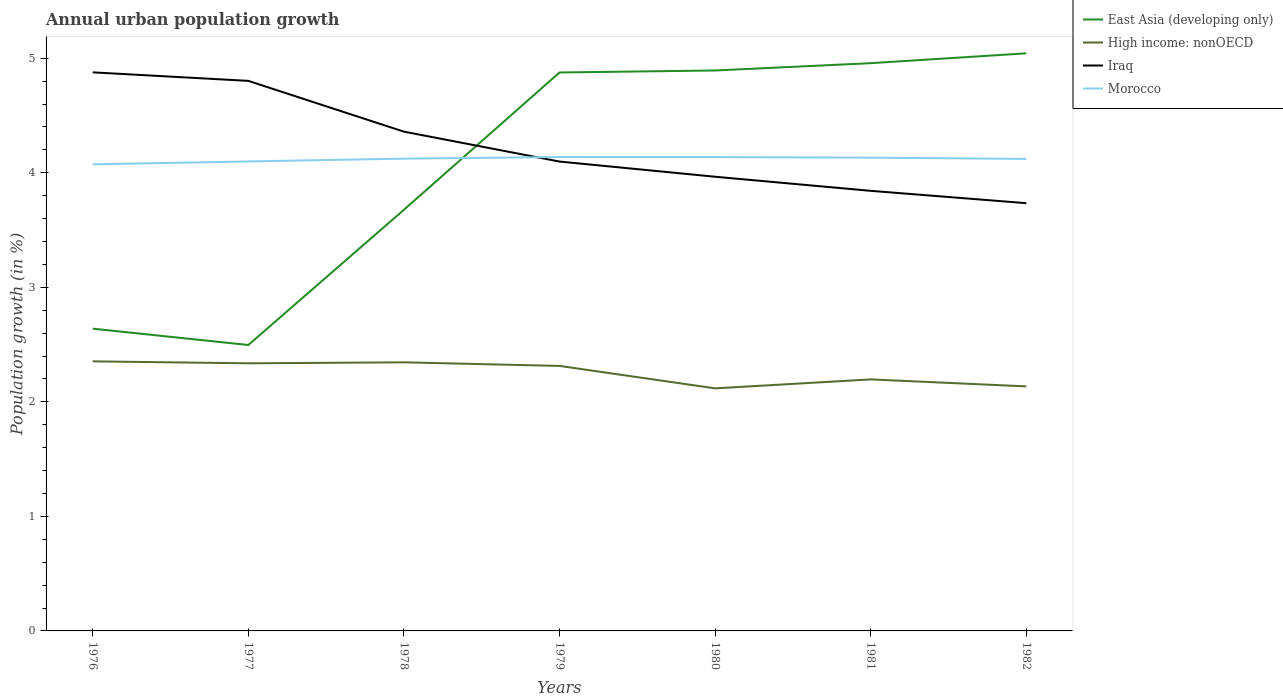How many different coloured lines are there?
Ensure brevity in your answer.  4. Does the line corresponding to Iraq intersect with the line corresponding to Morocco?
Give a very brief answer. Yes. Across all years, what is the maximum percentage of urban population growth in East Asia (developing only)?
Make the answer very short. 2.5. What is the total percentage of urban population growth in Iraq in the graph?
Give a very brief answer. 0.96. What is the difference between the highest and the second highest percentage of urban population growth in East Asia (developing only)?
Ensure brevity in your answer.  2.55. What is the difference between the highest and the lowest percentage of urban population growth in East Asia (developing only)?
Ensure brevity in your answer.  4. How many lines are there?
Make the answer very short. 4. Are the values on the major ticks of Y-axis written in scientific E-notation?
Keep it short and to the point. No. What is the title of the graph?
Your response must be concise. Annual urban population growth. Does "Belize" appear as one of the legend labels in the graph?
Make the answer very short. No. What is the label or title of the Y-axis?
Provide a succinct answer. Population growth (in %). What is the Population growth (in %) in East Asia (developing only) in 1976?
Ensure brevity in your answer.  2.64. What is the Population growth (in %) of High income: nonOECD in 1976?
Your response must be concise. 2.35. What is the Population growth (in %) of Iraq in 1976?
Your answer should be very brief. 4.88. What is the Population growth (in %) in Morocco in 1976?
Offer a very short reply. 4.07. What is the Population growth (in %) in East Asia (developing only) in 1977?
Your answer should be compact. 2.5. What is the Population growth (in %) in High income: nonOECD in 1977?
Provide a short and direct response. 2.34. What is the Population growth (in %) of Iraq in 1977?
Keep it short and to the point. 4.8. What is the Population growth (in %) in Morocco in 1977?
Give a very brief answer. 4.1. What is the Population growth (in %) in East Asia (developing only) in 1978?
Ensure brevity in your answer.  3.68. What is the Population growth (in %) of High income: nonOECD in 1978?
Make the answer very short. 2.35. What is the Population growth (in %) in Iraq in 1978?
Your answer should be compact. 4.36. What is the Population growth (in %) of Morocco in 1978?
Provide a succinct answer. 4.12. What is the Population growth (in %) in East Asia (developing only) in 1979?
Offer a very short reply. 4.88. What is the Population growth (in %) in High income: nonOECD in 1979?
Provide a succinct answer. 2.31. What is the Population growth (in %) of Iraq in 1979?
Ensure brevity in your answer.  4.1. What is the Population growth (in %) of Morocco in 1979?
Your answer should be compact. 4.14. What is the Population growth (in %) in East Asia (developing only) in 1980?
Offer a terse response. 4.89. What is the Population growth (in %) of High income: nonOECD in 1980?
Provide a succinct answer. 2.12. What is the Population growth (in %) of Iraq in 1980?
Offer a very short reply. 3.97. What is the Population growth (in %) of Morocco in 1980?
Your response must be concise. 4.14. What is the Population growth (in %) in East Asia (developing only) in 1981?
Provide a succinct answer. 4.96. What is the Population growth (in %) of High income: nonOECD in 1981?
Provide a succinct answer. 2.2. What is the Population growth (in %) in Iraq in 1981?
Your answer should be very brief. 3.84. What is the Population growth (in %) of Morocco in 1981?
Provide a succinct answer. 4.13. What is the Population growth (in %) in East Asia (developing only) in 1982?
Your answer should be compact. 5.04. What is the Population growth (in %) in High income: nonOECD in 1982?
Your response must be concise. 2.13. What is the Population growth (in %) of Iraq in 1982?
Offer a terse response. 3.73. What is the Population growth (in %) in Morocco in 1982?
Your response must be concise. 4.12. Across all years, what is the maximum Population growth (in %) of East Asia (developing only)?
Your answer should be compact. 5.04. Across all years, what is the maximum Population growth (in %) of High income: nonOECD?
Offer a terse response. 2.35. Across all years, what is the maximum Population growth (in %) in Iraq?
Your answer should be compact. 4.88. Across all years, what is the maximum Population growth (in %) of Morocco?
Your response must be concise. 4.14. Across all years, what is the minimum Population growth (in %) of East Asia (developing only)?
Your answer should be compact. 2.5. Across all years, what is the minimum Population growth (in %) in High income: nonOECD?
Provide a short and direct response. 2.12. Across all years, what is the minimum Population growth (in %) in Iraq?
Make the answer very short. 3.73. Across all years, what is the minimum Population growth (in %) in Morocco?
Make the answer very short. 4.07. What is the total Population growth (in %) in East Asia (developing only) in the graph?
Make the answer very short. 28.58. What is the total Population growth (in %) of High income: nonOECD in the graph?
Your response must be concise. 15.8. What is the total Population growth (in %) in Iraq in the graph?
Your answer should be compact. 29.68. What is the total Population growth (in %) of Morocco in the graph?
Your answer should be very brief. 28.82. What is the difference between the Population growth (in %) of East Asia (developing only) in 1976 and that in 1977?
Offer a terse response. 0.14. What is the difference between the Population growth (in %) in High income: nonOECD in 1976 and that in 1977?
Your answer should be compact. 0.02. What is the difference between the Population growth (in %) of Iraq in 1976 and that in 1977?
Your answer should be compact. 0.07. What is the difference between the Population growth (in %) in Morocco in 1976 and that in 1977?
Your answer should be compact. -0.03. What is the difference between the Population growth (in %) in East Asia (developing only) in 1976 and that in 1978?
Your response must be concise. -1.04. What is the difference between the Population growth (in %) of High income: nonOECD in 1976 and that in 1978?
Ensure brevity in your answer.  0.01. What is the difference between the Population growth (in %) in Iraq in 1976 and that in 1978?
Provide a succinct answer. 0.52. What is the difference between the Population growth (in %) of Morocco in 1976 and that in 1978?
Keep it short and to the point. -0.05. What is the difference between the Population growth (in %) in East Asia (developing only) in 1976 and that in 1979?
Provide a short and direct response. -2.24. What is the difference between the Population growth (in %) of Iraq in 1976 and that in 1979?
Make the answer very short. 0.78. What is the difference between the Population growth (in %) in Morocco in 1976 and that in 1979?
Make the answer very short. -0.06. What is the difference between the Population growth (in %) of East Asia (developing only) in 1976 and that in 1980?
Offer a terse response. -2.25. What is the difference between the Population growth (in %) of High income: nonOECD in 1976 and that in 1980?
Provide a short and direct response. 0.24. What is the difference between the Population growth (in %) of Iraq in 1976 and that in 1980?
Make the answer very short. 0.91. What is the difference between the Population growth (in %) of Morocco in 1976 and that in 1980?
Your answer should be compact. -0.06. What is the difference between the Population growth (in %) of East Asia (developing only) in 1976 and that in 1981?
Your answer should be very brief. -2.32. What is the difference between the Population growth (in %) in High income: nonOECD in 1976 and that in 1981?
Keep it short and to the point. 0.16. What is the difference between the Population growth (in %) in Iraq in 1976 and that in 1981?
Offer a very short reply. 1.03. What is the difference between the Population growth (in %) of Morocco in 1976 and that in 1981?
Your response must be concise. -0.06. What is the difference between the Population growth (in %) in East Asia (developing only) in 1976 and that in 1982?
Provide a short and direct response. -2.4. What is the difference between the Population growth (in %) in High income: nonOECD in 1976 and that in 1982?
Offer a terse response. 0.22. What is the difference between the Population growth (in %) in Iraq in 1976 and that in 1982?
Offer a very short reply. 1.14. What is the difference between the Population growth (in %) of Morocco in 1976 and that in 1982?
Ensure brevity in your answer.  -0.05. What is the difference between the Population growth (in %) of East Asia (developing only) in 1977 and that in 1978?
Your answer should be compact. -1.18. What is the difference between the Population growth (in %) in High income: nonOECD in 1977 and that in 1978?
Keep it short and to the point. -0.01. What is the difference between the Population growth (in %) of Iraq in 1977 and that in 1978?
Your response must be concise. 0.44. What is the difference between the Population growth (in %) of Morocco in 1977 and that in 1978?
Your response must be concise. -0.02. What is the difference between the Population growth (in %) in East Asia (developing only) in 1977 and that in 1979?
Keep it short and to the point. -2.38. What is the difference between the Population growth (in %) in High income: nonOECD in 1977 and that in 1979?
Your answer should be compact. 0.02. What is the difference between the Population growth (in %) of Iraq in 1977 and that in 1979?
Your answer should be compact. 0.7. What is the difference between the Population growth (in %) in Morocco in 1977 and that in 1979?
Your answer should be compact. -0.04. What is the difference between the Population growth (in %) in East Asia (developing only) in 1977 and that in 1980?
Provide a succinct answer. -2.4. What is the difference between the Population growth (in %) of High income: nonOECD in 1977 and that in 1980?
Your answer should be very brief. 0.22. What is the difference between the Population growth (in %) of Iraq in 1977 and that in 1980?
Offer a very short reply. 0.84. What is the difference between the Population growth (in %) of Morocco in 1977 and that in 1980?
Ensure brevity in your answer.  -0.04. What is the difference between the Population growth (in %) of East Asia (developing only) in 1977 and that in 1981?
Offer a very short reply. -2.46. What is the difference between the Population growth (in %) of High income: nonOECD in 1977 and that in 1981?
Provide a short and direct response. 0.14. What is the difference between the Population growth (in %) in Iraq in 1977 and that in 1981?
Keep it short and to the point. 0.96. What is the difference between the Population growth (in %) of Morocco in 1977 and that in 1981?
Provide a short and direct response. -0.03. What is the difference between the Population growth (in %) of East Asia (developing only) in 1977 and that in 1982?
Your answer should be very brief. -2.55. What is the difference between the Population growth (in %) of High income: nonOECD in 1977 and that in 1982?
Give a very brief answer. 0.2. What is the difference between the Population growth (in %) of Iraq in 1977 and that in 1982?
Make the answer very short. 1.07. What is the difference between the Population growth (in %) of Morocco in 1977 and that in 1982?
Your answer should be compact. -0.02. What is the difference between the Population growth (in %) of East Asia (developing only) in 1978 and that in 1979?
Ensure brevity in your answer.  -1.2. What is the difference between the Population growth (in %) of High income: nonOECD in 1978 and that in 1979?
Offer a terse response. 0.03. What is the difference between the Population growth (in %) in Iraq in 1978 and that in 1979?
Your response must be concise. 0.26. What is the difference between the Population growth (in %) in Morocco in 1978 and that in 1979?
Keep it short and to the point. -0.01. What is the difference between the Population growth (in %) of East Asia (developing only) in 1978 and that in 1980?
Provide a succinct answer. -1.22. What is the difference between the Population growth (in %) of High income: nonOECD in 1978 and that in 1980?
Offer a very short reply. 0.23. What is the difference between the Population growth (in %) of Iraq in 1978 and that in 1980?
Ensure brevity in your answer.  0.39. What is the difference between the Population growth (in %) of Morocco in 1978 and that in 1980?
Offer a very short reply. -0.01. What is the difference between the Population growth (in %) in East Asia (developing only) in 1978 and that in 1981?
Your answer should be compact. -1.28. What is the difference between the Population growth (in %) in High income: nonOECD in 1978 and that in 1981?
Your answer should be very brief. 0.15. What is the difference between the Population growth (in %) in Iraq in 1978 and that in 1981?
Provide a succinct answer. 0.52. What is the difference between the Population growth (in %) in Morocco in 1978 and that in 1981?
Provide a succinct answer. -0.01. What is the difference between the Population growth (in %) in East Asia (developing only) in 1978 and that in 1982?
Keep it short and to the point. -1.37. What is the difference between the Population growth (in %) in High income: nonOECD in 1978 and that in 1982?
Offer a terse response. 0.21. What is the difference between the Population growth (in %) of Iraq in 1978 and that in 1982?
Keep it short and to the point. 0.62. What is the difference between the Population growth (in %) of Morocco in 1978 and that in 1982?
Provide a succinct answer. 0. What is the difference between the Population growth (in %) of East Asia (developing only) in 1979 and that in 1980?
Offer a very short reply. -0.02. What is the difference between the Population growth (in %) of High income: nonOECD in 1979 and that in 1980?
Provide a short and direct response. 0.2. What is the difference between the Population growth (in %) in Iraq in 1979 and that in 1980?
Ensure brevity in your answer.  0.13. What is the difference between the Population growth (in %) in East Asia (developing only) in 1979 and that in 1981?
Your answer should be compact. -0.08. What is the difference between the Population growth (in %) of High income: nonOECD in 1979 and that in 1981?
Give a very brief answer. 0.12. What is the difference between the Population growth (in %) of Iraq in 1979 and that in 1981?
Give a very brief answer. 0.26. What is the difference between the Population growth (in %) of Morocco in 1979 and that in 1981?
Give a very brief answer. 0.01. What is the difference between the Population growth (in %) of East Asia (developing only) in 1979 and that in 1982?
Your answer should be very brief. -0.17. What is the difference between the Population growth (in %) in High income: nonOECD in 1979 and that in 1982?
Offer a very short reply. 0.18. What is the difference between the Population growth (in %) of Iraq in 1979 and that in 1982?
Your answer should be compact. 0.36. What is the difference between the Population growth (in %) in Morocco in 1979 and that in 1982?
Provide a short and direct response. 0.02. What is the difference between the Population growth (in %) of East Asia (developing only) in 1980 and that in 1981?
Your answer should be very brief. -0.06. What is the difference between the Population growth (in %) of High income: nonOECD in 1980 and that in 1981?
Provide a short and direct response. -0.08. What is the difference between the Population growth (in %) in Iraq in 1980 and that in 1981?
Keep it short and to the point. 0.12. What is the difference between the Population growth (in %) of Morocco in 1980 and that in 1981?
Offer a terse response. 0.01. What is the difference between the Population growth (in %) in East Asia (developing only) in 1980 and that in 1982?
Give a very brief answer. -0.15. What is the difference between the Population growth (in %) of High income: nonOECD in 1980 and that in 1982?
Keep it short and to the point. -0.02. What is the difference between the Population growth (in %) in Iraq in 1980 and that in 1982?
Your response must be concise. 0.23. What is the difference between the Population growth (in %) in Morocco in 1980 and that in 1982?
Give a very brief answer. 0.02. What is the difference between the Population growth (in %) in East Asia (developing only) in 1981 and that in 1982?
Your answer should be compact. -0.09. What is the difference between the Population growth (in %) in High income: nonOECD in 1981 and that in 1982?
Your answer should be very brief. 0.06. What is the difference between the Population growth (in %) in Iraq in 1981 and that in 1982?
Offer a very short reply. 0.11. What is the difference between the Population growth (in %) in Morocco in 1981 and that in 1982?
Provide a short and direct response. 0.01. What is the difference between the Population growth (in %) of East Asia (developing only) in 1976 and the Population growth (in %) of High income: nonOECD in 1977?
Your response must be concise. 0.3. What is the difference between the Population growth (in %) of East Asia (developing only) in 1976 and the Population growth (in %) of Iraq in 1977?
Provide a short and direct response. -2.16. What is the difference between the Population growth (in %) of East Asia (developing only) in 1976 and the Population growth (in %) of Morocco in 1977?
Offer a very short reply. -1.46. What is the difference between the Population growth (in %) of High income: nonOECD in 1976 and the Population growth (in %) of Iraq in 1977?
Your response must be concise. -2.45. What is the difference between the Population growth (in %) of High income: nonOECD in 1976 and the Population growth (in %) of Morocco in 1977?
Give a very brief answer. -1.75. What is the difference between the Population growth (in %) of Iraq in 1976 and the Population growth (in %) of Morocco in 1977?
Offer a very short reply. 0.78. What is the difference between the Population growth (in %) of East Asia (developing only) in 1976 and the Population growth (in %) of High income: nonOECD in 1978?
Keep it short and to the point. 0.29. What is the difference between the Population growth (in %) in East Asia (developing only) in 1976 and the Population growth (in %) in Iraq in 1978?
Ensure brevity in your answer.  -1.72. What is the difference between the Population growth (in %) of East Asia (developing only) in 1976 and the Population growth (in %) of Morocco in 1978?
Ensure brevity in your answer.  -1.48. What is the difference between the Population growth (in %) of High income: nonOECD in 1976 and the Population growth (in %) of Iraq in 1978?
Provide a short and direct response. -2.01. What is the difference between the Population growth (in %) in High income: nonOECD in 1976 and the Population growth (in %) in Morocco in 1978?
Ensure brevity in your answer.  -1.77. What is the difference between the Population growth (in %) in Iraq in 1976 and the Population growth (in %) in Morocco in 1978?
Ensure brevity in your answer.  0.75. What is the difference between the Population growth (in %) in East Asia (developing only) in 1976 and the Population growth (in %) in High income: nonOECD in 1979?
Provide a succinct answer. 0.33. What is the difference between the Population growth (in %) of East Asia (developing only) in 1976 and the Population growth (in %) of Iraq in 1979?
Offer a very short reply. -1.46. What is the difference between the Population growth (in %) of East Asia (developing only) in 1976 and the Population growth (in %) of Morocco in 1979?
Your response must be concise. -1.5. What is the difference between the Population growth (in %) of High income: nonOECD in 1976 and the Population growth (in %) of Iraq in 1979?
Offer a very short reply. -1.74. What is the difference between the Population growth (in %) in High income: nonOECD in 1976 and the Population growth (in %) in Morocco in 1979?
Make the answer very short. -1.78. What is the difference between the Population growth (in %) in Iraq in 1976 and the Population growth (in %) in Morocco in 1979?
Your response must be concise. 0.74. What is the difference between the Population growth (in %) in East Asia (developing only) in 1976 and the Population growth (in %) in High income: nonOECD in 1980?
Your answer should be very brief. 0.52. What is the difference between the Population growth (in %) in East Asia (developing only) in 1976 and the Population growth (in %) in Iraq in 1980?
Offer a terse response. -1.33. What is the difference between the Population growth (in %) of East Asia (developing only) in 1976 and the Population growth (in %) of Morocco in 1980?
Your answer should be compact. -1.5. What is the difference between the Population growth (in %) of High income: nonOECD in 1976 and the Population growth (in %) of Iraq in 1980?
Provide a succinct answer. -1.61. What is the difference between the Population growth (in %) in High income: nonOECD in 1976 and the Population growth (in %) in Morocco in 1980?
Give a very brief answer. -1.78. What is the difference between the Population growth (in %) in Iraq in 1976 and the Population growth (in %) in Morocco in 1980?
Offer a terse response. 0.74. What is the difference between the Population growth (in %) of East Asia (developing only) in 1976 and the Population growth (in %) of High income: nonOECD in 1981?
Offer a terse response. 0.44. What is the difference between the Population growth (in %) in East Asia (developing only) in 1976 and the Population growth (in %) in Iraq in 1981?
Your answer should be very brief. -1.2. What is the difference between the Population growth (in %) of East Asia (developing only) in 1976 and the Population growth (in %) of Morocco in 1981?
Provide a succinct answer. -1.49. What is the difference between the Population growth (in %) of High income: nonOECD in 1976 and the Population growth (in %) of Iraq in 1981?
Make the answer very short. -1.49. What is the difference between the Population growth (in %) in High income: nonOECD in 1976 and the Population growth (in %) in Morocco in 1981?
Your answer should be compact. -1.78. What is the difference between the Population growth (in %) in Iraq in 1976 and the Population growth (in %) in Morocco in 1981?
Give a very brief answer. 0.74. What is the difference between the Population growth (in %) of East Asia (developing only) in 1976 and the Population growth (in %) of High income: nonOECD in 1982?
Offer a very short reply. 0.5. What is the difference between the Population growth (in %) in East Asia (developing only) in 1976 and the Population growth (in %) in Iraq in 1982?
Ensure brevity in your answer.  -1.1. What is the difference between the Population growth (in %) in East Asia (developing only) in 1976 and the Population growth (in %) in Morocco in 1982?
Offer a terse response. -1.48. What is the difference between the Population growth (in %) of High income: nonOECD in 1976 and the Population growth (in %) of Iraq in 1982?
Offer a very short reply. -1.38. What is the difference between the Population growth (in %) of High income: nonOECD in 1976 and the Population growth (in %) of Morocco in 1982?
Provide a succinct answer. -1.77. What is the difference between the Population growth (in %) of Iraq in 1976 and the Population growth (in %) of Morocco in 1982?
Ensure brevity in your answer.  0.76. What is the difference between the Population growth (in %) in East Asia (developing only) in 1977 and the Population growth (in %) in High income: nonOECD in 1978?
Keep it short and to the point. 0.15. What is the difference between the Population growth (in %) in East Asia (developing only) in 1977 and the Population growth (in %) in Iraq in 1978?
Your answer should be compact. -1.86. What is the difference between the Population growth (in %) of East Asia (developing only) in 1977 and the Population growth (in %) of Morocco in 1978?
Give a very brief answer. -1.63. What is the difference between the Population growth (in %) in High income: nonOECD in 1977 and the Population growth (in %) in Iraq in 1978?
Ensure brevity in your answer.  -2.02. What is the difference between the Population growth (in %) in High income: nonOECD in 1977 and the Population growth (in %) in Morocco in 1978?
Keep it short and to the point. -1.79. What is the difference between the Population growth (in %) in Iraq in 1977 and the Population growth (in %) in Morocco in 1978?
Offer a very short reply. 0.68. What is the difference between the Population growth (in %) of East Asia (developing only) in 1977 and the Population growth (in %) of High income: nonOECD in 1979?
Provide a short and direct response. 0.18. What is the difference between the Population growth (in %) in East Asia (developing only) in 1977 and the Population growth (in %) in Iraq in 1979?
Provide a short and direct response. -1.6. What is the difference between the Population growth (in %) of East Asia (developing only) in 1977 and the Population growth (in %) of Morocco in 1979?
Provide a short and direct response. -1.64. What is the difference between the Population growth (in %) of High income: nonOECD in 1977 and the Population growth (in %) of Iraq in 1979?
Give a very brief answer. -1.76. What is the difference between the Population growth (in %) in High income: nonOECD in 1977 and the Population growth (in %) in Morocco in 1979?
Offer a terse response. -1.8. What is the difference between the Population growth (in %) in Iraq in 1977 and the Population growth (in %) in Morocco in 1979?
Provide a succinct answer. 0.66. What is the difference between the Population growth (in %) of East Asia (developing only) in 1977 and the Population growth (in %) of High income: nonOECD in 1980?
Provide a short and direct response. 0.38. What is the difference between the Population growth (in %) of East Asia (developing only) in 1977 and the Population growth (in %) of Iraq in 1980?
Give a very brief answer. -1.47. What is the difference between the Population growth (in %) of East Asia (developing only) in 1977 and the Population growth (in %) of Morocco in 1980?
Make the answer very short. -1.64. What is the difference between the Population growth (in %) in High income: nonOECD in 1977 and the Population growth (in %) in Iraq in 1980?
Your response must be concise. -1.63. What is the difference between the Population growth (in %) of High income: nonOECD in 1977 and the Population growth (in %) of Morocco in 1980?
Provide a succinct answer. -1.8. What is the difference between the Population growth (in %) of Iraq in 1977 and the Population growth (in %) of Morocco in 1980?
Offer a very short reply. 0.67. What is the difference between the Population growth (in %) in East Asia (developing only) in 1977 and the Population growth (in %) in High income: nonOECD in 1981?
Your answer should be very brief. 0.3. What is the difference between the Population growth (in %) in East Asia (developing only) in 1977 and the Population growth (in %) in Iraq in 1981?
Provide a short and direct response. -1.35. What is the difference between the Population growth (in %) of East Asia (developing only) in 1977 and the Population growth (in %) of Morocco in 1981?
Your answer should be compact. -1.64. What is the difference between the Population growth (in %) of High income: nonOECD in 1977 and the Population growth (in %) of Iraq in 1981?
Provide a short and direct response. -1.51. What is the difference between the Population growth (in %) in High income: nonOECD in 1977 and the Population growth (in %) in Morocco in 1981?
Provide a short and direct response. -1.8. What is the difference between the Population growth (in %) in Iraq in 1977 and the Population growth (in %) in Morocco in 1981?
Provide a short and direct response. 0.67. What is the difference between the Population growth (in %) in East Asia (developing only) in 1977 and the Population growth (in %) in High income: nonOECD in 1982?
Offer a terse response. 0.36. What is the difference between the Population growth (in %) of East Asia (developing only) in 1977 and the Population growth (in %) of Iraq in 1982?
Keep it short and to the point. -1.24. What is the difference between the Population growth (in %) of East Asia (developing only) in 1977 and the Population growth (in %) of Morocco in 1982?
Provide a succinct answer. -1.62. What is the difference between the Population growth (in %) in High income: nonOECD in 1977 and the Population growth (in %) in Iraq in 1982?
Your response must be concise. -1.4. What is the difference between the Population growth (in %) of High income: nonOECD in 1977 and the Population growth (in %) of Morocco in 1982?
Provide a succinct answer. -1.78. What is the difference between the Population growth (in %) of Iraq in 1977 and the Population growth (in %) of Morocco in 1982?
Your answer should be very brief. 0.68. What is the difference between the Population growth (in %) of East Asia (developing only) in 1978 and the Population growth (in %) of High income: nonOECD in 1979?
Give a very brief answer. 1.36. What is the difference between the Population growth (in %) of East Asia (developing only) in 1978 and the Population growth (in %) of Iraq in 1979?
Ensure brevity in your answer.  -0.42. What is the difference between the Population growth (in %) of East Asia (developing only) in 1978 and the Population growth (in %) of Morocco in 1979?
Offer a terse response. -0.46. What is the difference between the Population growth (in %) of High income: nonOECD in 1978 and the Population growth (in %) of Iraq in 1979?
Provide a succinct answer. -1.75. What is the difference between the Population growth (in %) in High income: nonOECD in 1978 and the Population growth (in %) in Morocco in 1979?
Your response must be concise. -1.79. What is the difference between the Population growth (in %) of Iraq in 1978 and the Population growth (in %) of Morocco in 1979?
Offer a very short reply. 0.22. What is the difference between the Population growth (in %) of East Asia (developing only) in 1978 and the Population growth (in %) of High income: nonOECD in 1980?
Ensure brevity in your answer.  1.56. What is the difference between the Population growth (in %) in East Asia (developing only) in 1978 and the Population growth (in %) in Iraq in 1980?
Make the answer very short. -0.29. What is the difference between the Population growth (in %) of East Asia (developing only) in 1978 and the Population growth (in %) of Morocco in 1980?
Provide a short and direct response. -0.46. What is the difference between the Population growth (in %) in High income: nonOECD in 1978 and the Population growth (in %) in Iraq in 1980?
Your answer should be very brief. -1.62. What is the difference between the Population growth (in %) of High income: nonOECD in 1978 and the Population growth (in %) of Morocco in 1980?
Offer a terse response. -1.79. What is the difference between the Population growth (in %) of Iraq in 1978 and the Population growth (in %) of Morocco in 1980?
Offer a terse response. 0.22. What is the difference between the Population growth (in %) of East Asia (developing only) in 1978 and the Population growth (in %) of High income: nonOECD in 1981?
Give a very brief answer. 1.48. What is the difference between the Population growth (in %) in East Asia (developing only) in 1978 and the Population growth (in %) in Iraq in 1981?
Ensure brevity in your answer.  -0.17. What is the difference between the Population growth (in %) of East Asia (developing only) in 1978 and the Population growth (in %) of Morocco in 1981?
Offer a very short reply. -0.46. What is the difference between the Population growth (in %) in High income: nonOECD in 1978 and the Population growth (in %) in Iraq in 1981?
Offer a terse response. -1.5. What is the difference between the Population growth (in %) in High income: nonOECD in 1978 and the Population growth (in %) in Morocco in 1981?
Your answer should be very brief. -1.79. What is the difference between the Population growth (in %) of Iraq in 1978 and the Population growth (in %) of Morocco in 1981?
Provide a succinct answer. 0.23. What is the difference between the Population growth (in %) of East Asia (developing only) in 1978 and the Population growth (in %) of High income: nonOECD in 1982?
Your answer should be very brief. 1.54. What is the difference between the Population growth (in %) in East Asia (developing only) in 1978 and the Population growth (in %) in Iraq in 1982?
Provide a short and direct response. -0.06. What is the difference between the Population growth (in %) of East Asia (developing only) in 1978 and the Population growth (in %) of Morocco in 1982?
Provide a short and direct response. -0.44. What is the difference between the Population growth (in %) of High income: nonOECD in 1978 and the Population growth (in %) of Iraq in 1982?
Give a very brief answer. -1.39. What is the difference between the Population growth (in %) in High income: nonOECD in 1978 and the Population growth (in %) in Morocco in 1982?
Give a very brief answer. -1.78. What is the difference between the Population growth (in %) of Iraq in 1978 and the Population growth (in %) of Morocco in 1982?
Your response must be concise. 0.24. What is the difference between the Population growth (in %) of East Asia (developing only) in 1979 and the Population growth (in %) of High income: nonOECD in 1980?
Your answer should be very brief. 2.76. What is the difference between the Population growth (in %) of East Asia (developing only) in 1979 and the Population growth (in %) of Iraq in 1980?
Your answer should be very brief. 0.91. What is the difference between the Population growth (in %) in East Asia (developing only) in 1979 and the Population growth (in %) in Morocco in 1980?
Your answer should be compact. 0.74. What is the difference between the Population growth (in %) in High income: nonOECD in 1979 and the Population growth (in %) in Iraq in 1980?
Ensure brevity in your answer.  -1.65. What is the difference between the Population growth (in %) in High income: nonOECD in 1979 and the Population growth (in %) in Morocco in 1980?
Keep it short and to the point. -1.82. What is the difference between the Population growth (in %) in Iraq in 1979 and the Population growth (in %) in Morocco in 1980?
Provide a succinct answer. -0.04. What is the difference between the Population growth (in %) of East Asia (developing only) in 1979 and the Population growth (in %) of High income: nonOECD in 1981?
Provide a short and direct response. 2.68. What is the difference between the Population growth (in %) in East Asia (developing only) in 1979 and the Population growth (in %) in Iraq in 1981?
Your response must be concise. 1.03. What is the difference between the Population growth (in %) of East Asia (developing only) in 1979 and the Population growth (in %) of Morocco in 1981?
Offer a terse response. 0.74. What is the difference between the Population growth (in %) in High income: nonOECD in 1979 and the Population growth (in %) in Iraq in 1981?
Provide a succinct answer. -1.53. What is the difference between the Population growth (in %) of High income: nonOECD in 1979 and the Population growth (in %) of Morocco in 1981?
Ensure brevity in your answer.  -1.82. What is the difference between the Population growth (in %) of Iraq in 1979 and the Population growth (in %) of Morocco in 1981?
Your response must be concise. -0.03. What is the difference between the Population growth (in %) of East Asia (developing only) in 1979 and the Population growth (in %) of High income: nonOECD in 1982?
Ensure brevity in your answer.  2.74. What is the difference between the Population growth (in %) in East Asia (developing only) in 1979 and the Population growth (in %) in Iraq in 1982?
Your response must be concise. 1.14. What is the difference between the Population growth (in %) of East Asia (developing only) in 1979 and the Population growth (in %) of Morocco in 1982?
Your answer should be compact. 0.75. What is the difference between the Population growth (in %) of High income: nonOECD in 1979 and the Population growth (in %) of Iraq in 1982?
Your answer should be very brief. -1.42. What is the difference between the Population growth (in %) of High income: nonOECD in 1979 and the Population growth (in %) of Morocco in 1982?
Give a very brief answer. -1.81. What is the difference between the Population growth (in %) of Iraq in 1979 and the Population growth (in %) of Morocco in 1982?
Offer a very short reply. -0.02. What is the difference between the Population growth (in %) in East Asia (developing only) in 1980 and the Population growth (in %) in High income: nonOECD in 1981?
Provide a succinct answer. 2.7. What is the difference between the Population growth (in %) of East Asia (developing only) in 1980 and the Population growth (in %) of Iraq in 1981?
Offer a terse response. 1.05. What is the difference between the Population growth (in %) of East Asia (developing only) in 1980 and the Population growth (in %) of Morocco in 1981?
Your answer should be compact. 0.76. What is the difference between the Population growth (in %) of High income: nonOECD in 1980 and the Population growth (in %) of Iraq in 1981?
Your answer should be very brief. -1.72. What is the difference between the Population growth (in %) in High income: nonOECD in 1980 and the Population growth (in %) in Morocco in 1981?
Give a very brief answer. -2.01. What is the difference between the Population growth (in %) of Iraq in 1980 and the Population growth (in %) of Morocco in 1981?
Give a very brief answer. -0.17. What is the difference between the Population growth (in %) of East Asia (developing only) in 1980 and the Population growth (in %) of High income: nonOECD in 1982?
Provide a short and direct response. 2.76. What is the difference between the Population growth (in %) in East Asia (developing only) in 1980 and the Population growth (in %) in Iraq in 1982?
Provide a short and direct response. 1.16. What is the difference between the Population growth (in %) of East Asia (developing only) in 1980 and the Population growth (in %) of Morocco in 1982?
Your answer should be compact. 0.77. What is the difference between the Population growth (in %) in High income: nonOECD in 1980 and the Population growth (in %) in Iraq in 1982?
Ensure brevity in your answer.  -1.62. What is the difference between the Population growth (in %) of High income: nonOECD in 1980 and the Population growth (in %) of Morocco in 1982?
Offer a terse response. -2. What is the difference between the Population growth (in %) in Iraq in 1980 and the Population growth (in %) in Morocco in 1982?
Keep it short and to the point. -0.16. What is the difference between the Population growth (in %) in East Asia (developing only) in 1981 and the Population growth (in %) in High income: nonOECD in 1982?
Give a very brief answer. 2.82. What is the difference between the Population growth (in %) in East Asia (developing only) in 1981 and the Population growth (in %) in Iraq in 1982?
Your response must be concise. 1.22. What is the difference between the Population growth (in %) of East Asia (developing only) in 1981 and the Population growth (in %) of Morocco in 1982?
Ensure brevity in your answer.  0.84. What is the difference between the Population growth (in %) in High income: nonOECD in 1981 and the Population growth (in %) in Iraq in 1982?
Ensure brevity in your answer.  -1.54. What is the difference between the Population growth (in %) of High income: nonOECD in 1981 and the Population growth (in %) of Morocco in 1982?
Give a very brief answer. -1.93. What is the difference between the Population growth (in %) of Iraq in 1981 and the Population growth (in %) of Morocco in 1982?
Your answer should be compact. -0.28. What is the average Population growth (in %) in East Asia (developing only) per year?
Ensure brevity in your answer.  4.08. What is the average Population growth (in %) in High income: nonOECD per year?
Offer a terse response. 2.26. What is the average Population growth (in %) of Iraq per year?
Give a very brief answer. 4.24. What is the average Population growth (in %) of Morocco per year?
Your answer should be very brief. 4.12. In the year 1976, what is the difference between the Population growth (in %) in East Asia (developing only) and Population growth (in %) in High income: nonOECD?
Provide a succinct answer. 0.29. In the year 1976, what is the difference between the Population growth (in %) in East Asia (developing only) and Population growth (in %) in Iraq?
Provide a short and direct response. -2.24. In the year 1976, what is the difference between the Population growth (in %) of East Asia (developing only) and Population growth (in %) of Morocco?
Offer a very short reply. -1.43. In the year 1976, what is the difference between the Population growth (in %) of High income: nonOECD and Population growth (in %) of Iraq?
Ensure brevity in your answer.  -2.52. In the year 1976, what is the difference between the Population growth (in %) of High income: nonOECD and Population growth (in %) of Morocco?
Give a very brief answer. -1.72. In the year 1976, what is the difference between the Population growth (in %) of Iraq and Population growth (in %) of Morocco?
Your answer should be compact. 0.8. In the year 1977, what is the difference between the Population growth (in %) of East Asia (developing only) and Population growth (in %) of High income: nonOECD?
Keep it short and to the point. 0.16. In the year 1977, what is the difference between the Population growth (in %) in East Asia (developing only) and Population growth (in %) in Iraq?
Ensure brevity in your answer.  -2.31. In the year 1977, what is the difference between the Population growth (in %) of East Asia (developing only) and Population growth (in %) of Morocco?
Your answer should be compact. -1.6. In the year 1977, what is the difference between the Population growth (in %) of High income: nonOECD and Population growth (in %) of Iraq?
Offer a very short reply. -2.47. In the year 1977, what is the difference between the Population growth (in %) in High income: nonOECD and Population growth (in %) in Morocco?
Provide a short and direct response. -1.76. In the year 1977, what is the difference between the Population growth (in %) in Iraq and Population growth (in %) in Morocco?
Keep it short and to the point. 0.7. In the year 1978, what is the difference between the Population growth (in %) of East Asia (developing only) and Population growth (in %) of High income: nonOECD?
Provide a short and direct response. 1.33. In the year 1978, what is the difference between the Population growth (in %) in East Asia (developing only) and Population growth (in %) in Iraq?
Your response must be concise. -0.68. In the year 1978, what is the difference between the Population growth (in %) in East Asia (developing only) and Population growth (in %) in Morocco?
Keep it short and to the point. -0.45. In the year 1978, what is the difference between the Population growth (in %) of High income: nonOECD and Population growth (in %) of Iraq?
Ensure brevity in your answer.  -2.01. In the year 1978, what is the difference between the Population growth (in %) of High income: nonOECD and Population growth (in %) of Morocco?
Your response must be concise. -1.78. In the year 1978, what is the difference between the Population growth (in %) of Iraq and Population growth (in %) of Morocco?
Keep it short and to the point. 0.24. In the year 1979, what is the difference between the Population growth (in %) of East Asia (developing only) and Population growth (in %) of High income: nonOECD?
Give a very brief answer. 2.56. In the year 1979, what is the difference between the Population growth (in %) of East Asia (developing only) and Population growth (in %) of Iraq?
Offer a terse response. 0.78. In the year 1979, what is the difference between the Population growth (in %) of East Asia (developing only) and Population growth (in %) of Morocco?
Give a very brief answer. 0.74. In the year 1979, what is the difference between the Population growth (in %) of High income: nonOECD and Population growth (in %) of Iraq?
Ensure brevity in your answer.  -1.78. In the year 1979, what is the difference between the Population growth (in %) in High income: nonOECD and Population growth (in %) in Morocco?
Make the answer very short. -1.82. In the year 1979, what is the difference between the Population growth (in %) of Iraq and Population growth (in %) of Morocco?
Ensure brevity in your answer.  -0.04. In the year 1980, what is the difference between the Population growth (in %) of East Asia (developing only) and Population growth (in %) of High income: nonOECD?
Provide a short and direct response. 2.78. In the year 1980, what is the difference between the Population growth (in %) of East Asia (developing only) and Population growth (in %) of Iraq?
Offer a terse response. 0.93. In the year 1980, what is the difference between the Population growth (in %) of East Asia (developing only) and Population growth (in %) of Morocco?
Offer a terse response. 0.76. In the year 1980, what is the difference between the Population growth (in %) of High income: nonOECD and Population growth (in %) of Iraq?
Your answer should be compact. -1.85. In the year 1980, what is the difference between the Population growth (in %) of High income: nonOECD and Population growth (in %) of Morocco?
Offer a very short reply. -2.02. In the year 1980, what is the difference between the Population growth (in %) of Iraq and Population growth (in %) of Morocco?
Provide a short and direct response. -0.17. In the year 1981, what is the difference between the Population growth (in %) in East Asia (developing only) and Population growth (in %) in High income: nonOECD?
Make the answer very short. 2.76. In the year 1981, what is the difference between the Population growth (in %) in East Asia (developing only) and Population growth (in %) in Iraq?
Keep it short and to the point. 1.11. In the year 1981, what is the difference between the Population growth (in %) in East Asia (developing only) and Population growth (in %) in Morocco?
Offer a very short reply. 0.82. In the year 1981, what is the difference between the Population growth (in %) of High income: nonOECD and Population growth (in %) of Iraq?
Provide a succinct answer. -1.65. In the year 1981, what is the difference between the Population growth (in %) of High income: nonOECD and Population growth (in %) of Morocco?
Your answer should be very brief. -1.94. In the year 1981, what is the difference between the Population growth (in %) in Iraq and Population growth (in %) in Morocco?
Provide a short and direct response. -0.29. In the year 1982, what is the difference between the Population growth (in %) of East Asia (developing only) and Population growth (in %) of High income: nonOECD?
Provide a short and direct response. 2.91. In the year 1982, what is the difference between the Population growth (in %) in East Asia (developing only) and Population growth (in %) in Iraq?
Offer a very short reply. 1.31. In the year 1982, what is the difference between the Population growth (in %) in East Asia (developing only) and Population growth (in %) in Morocco?
Your response must be concise. 0.92. In the year 1982, what is the difference between the Population growth (in %) in High income: nonOECD and Population growth (in %) in Iraq?
Offer a terse response. -1.6. In the year 1982, what is the difference between the Population growth (in %) of High income: nonOECD and Population growth (in %) of Morocco?
Your answer should be compact. -1.99. In the year 1982, what is the difference between the Population growth (in %) in Iraq and Population growth (in %) in Morocco?
Your answer should be very brief. -0.39. What is the ratio of the Population growth (in %) in East Asia (developing only) in 1976 to that in 1977?
Your answer should be very brief. 1.06. What is the ratio of the Population growth (in %) of High income: nonOECD in 1976 to that in 1977?
Ensure brevity in your answer.  1.01. What is the ratio of the Population growth (in %) of Iraq in 1976 to that in 1977?
Provide a succinct answer. 1.02. What is the ratio of the Population growth (in %) in East Asia (developing only) in 1976 to that in 1978?
Give a very brief answer. 0.72. What is the ratio of the Population growth (in %) of High income: nonOECD in 1976 to that in 1978?
Keep it short and to the point. 1. What is the ratio of the Population growth (in %) of Iraq in 1976 to that in 1978?
Your response must be concise. 1.12. What is the ratio of the Population growth (in %) of Morocco in 1976 to that in 1978?
Offer a very short reply. 0.99. What is the ratio of the Population growth (in %) in East Asia (developing only) in 1976 to that in 1979?
Ensure brevity in your answer.  0.54. What is the ratio of the Population growth (in %) in High income: nonOECD in 1976 to that in 1979?
Your response must be concise. 1.02. What is the ratio of the Population growth (in %) of Iraq in 1976 to that in 1979?
Offer a very short reply. 1.19. What is the ratio of the Population growth (in %) of Morocco in 1976 to that in 1979?
Ensure brevity in your answer.  0.98. What is the ratio of the Population growth (in %) in East Asia (developing only) in 1976 to that in 1980?
Ensure brevity in your answer.  0.54. What is the ratio of the Population growth (in %) of High income: nonOECD in 1976 to that in 1980?
Your answer should be compact. 1.11. What is the ratio of the Population growth (in %) in Iraq in 1976 to that in 1980?
Offer a very short reply. 1.23. What is the ratio of the Population growth (in %) of Morocco in 1976 to that in 1980?
Make the answer very short. 0.98. What is the ratio of the Population growth (in %) of East Asia (developing only) in 1976 to that in 1981?
Offer a very short reply. 0.53. What is the ratio of the Population growth (in %) of High income: nonOECD in 1976 to that in 1981?
Give a very brief answer. 1.07. What is the ratio of the Population growth (in %) in Iraq in 1976 to that in 1981?
Offer a terse response. 1.27. What is the ratio of the Population growth (in %) of Morocco in 1976 to that in 1981?
Your answer should be compact. 0.99. What is the ratio of the Population growth (in %) in East Asia (developing only) in 1976 to that in 1982?
Make the answer very short. 0.52. What is the ratio of the Population growth (in %) in High income: nonOECD in 1976 to that in 1982?
Provide a succinct answer. 1.1. What is the ratio of the Population growth (in %) in Iraq in 1976 to that in 1982?
Ensure brevity in your answer.  1.31. What is the ratio of the Population growth (in %) of Morocco in 1976 to that in 1982?
Your answer should be very brief. 0.99. What is the ratio of the Population growth (in %) in East Asia (developing only) in 1977 to that in 1978?
Offer a very short reply. 0.68. What is the ratio of the Population growth (in %) in High income: nonOECD in 1977 to that in 1978?
Offer a very short reply. 1. What is the ratio of the Population growth (in %) in Iraq in 1977 to that in 1978?
Give a very brief answer. 1.1. What is the ratio of the Population growth (in %) in East Asia (developing only) in 1977 to that in 1979?
Give a very brief answer. 0.51. What is the ratio of the Population growth (in %) of High income: nonOECD in 1977 to that in 1979?
Give a very brief answer. 1.01. What is the ratio of the Population growth (in %) of Iraq in 1977 to that in 1979?
Keep it short and to the point. 1.17. What is the ratio of the Population growth (in %) in Morocco in 1977 to that in 1979?
Your answer should be very brief. 0.99. What is the ratio of the Population growth (in %) in East Asia (developing only) in 1977 to that in 1980?
Provide a short and direct response. 0.51. What is the ratio of the Population growth (in %) of High income: nonOECD in 1977 to that in 1980?
Keep it short and to the point. 1.1. What is the ratio of the Population growth (in %) in Iraq in 1977 to that in 1980?
Make the answer very short. 1.21. What is the ratio of the Population growth (in %) in East Asia (developing only) in 1977 to that in 1981?
Provide a succinct answer. 0.5. What is the ratio of the Population growth (in %) of High income: nonOECD in 1977 to that in 1981?
Ensure brevity in your answer.  1.06. What is the ratio of the Population growth (in %) of Iraq in 1977 to that in 1981?
Provide a succinct answer. 1.25. What is the ratio of the Population growth (in %) in East Asia (developing only) in 1977 to that in 1982?
Make the answer very short. 0.49. What is the ratio of the Population growth (in %) of High income: nonOECD in 1977 to that in 1982?
Make the answer very short. 1.09. What is the ratio of the Population growth (in %) in Iraq in 1977 to that in 1982?
Give a very brief answer. 1.29. What is the ratio of the Population growth (in %) of East Asia (developing only) in 1978 to that in 1979?
Ensure brevity in your answer.  0.75. What is the ratio of the Population growth (in %) of High income: nonOECD in 1978 to that in 1979?
Your answer should be compact. 1.01. What is the ratio of the Population growth (in %) of Iraq in 1978 to that in 1979?
Ensure brevity in your answer.  1.06. What is the ratio of the Population growth (in %) of Morocco in 1978 to that in 1979?
Give a very brief answer. 1. What is the ratio of the Population growth (in %) in East Asia (developing only) in 1978 to that in 1980?
Ensure brevity in your answer.  0.75. What is the ratio of the Population growth (in %) in High income: nonOECD in 1978 to that in 1980?
Your response must be concise. 1.11. What is the ratio of the Population growth (in %) in Iraq in 1978 to that in 1980?
Give a very brief answer. 1.1. What is the ratio of the Population growth (in %) in East Asia (developing only) in 1978 to that in 1981?
Your answer should be very brief. 0.74. What is the ratio of the Population growth (in %) of High income: nonOECD in 1978 to that in 1981?
Provide a succinct answer. 1.07. What is the ratio of the Population growth (in %) in Iraq in 1978 to that in 1981?
Offer a terse response. 1.13. What is the ratio of the Population growth (in %) in East Asia (developing only) in 1978 to that in 1982?
Your answer should be very brief. 0.73. What is the ratio of the Population growth (in %) in High income: nonOECD in 1978 to that in 1982?
Your response must be concise. 1.1. What is the ratio of the Population growth (in %) in Iraq in 1978 to that in 1982?
Offer a terse response. 1.17. What is the ratio of the Population growth (in %) in Morocco in 1978 to that in 1982?
Offer a very short reply. 1. What is the ratio of the Population growth (in %) of East Asia (developing only) in 1979 to that in 1980?
Your answer should be compact. 1. What is the ratio of the Population growth (in %) in High income: nonOECD in 1979 to that in 1980?
Your answer should be very brief. 1.09. What is the ratio of the Population growth (in %) of Iraq in 1979 to that in 1980?
Offer a terse response. 1.03. What is the ratio of the Population growth (in %) in East Asia (developing only) in 1979 to that in 1981?
Your response must be concise. 0.98. What is the ratio of the Population growth (in %) of High income: nonOECD in 1979 to that in 1981?
Your response must be concise. 1.05. What is the ratio of the Population growth (in %) of Iraq in 1979 to that in 1981?
Provide a succinct answer. 1.07. What is the ratio of the Population growth (in %) in Morocco in 1979 to that in 1981?
Ensure brevity in your answer.  1. What is the ratio of the Population growth (in %) in East Asia (developing only) in 1979 to that in 1982?
Offer a very short reply. 0.97. What is the ratio of the Population growth (in %) in High income: nonOECD in 1979 to that in 1982?
Offer a terse response. 1.08. What is the ratio of the Population growth (in %) in Iraq in 1979 to that in 1982?
Your answer should be very brief. 1.1. What is the ratio of the Population growth (in %) of East Asia (developing only) in 1980 to that in 1981?
Make the answer very short. 0.99. What is the ratio of the Population growth (in %) in High income: nonOECD in 1980 to that in 1981?
Give a very brief answer. 0.96. What is the ratio of the Population growth (in %) in Iraq in 1980 to that in 1981?
Your answer should be compact. 1.03. What is the ratio of the Population growth (in %) of Morocco in 1980 to that in 1981?
Provide a succinct answer. 1. What is the ratio of the Population growth (in %) in East Asia (developing only) in 1980 to that in 1982?
Provide a short and direct response. 0.97. What is the ratio of the Population growth (in %) in High income: nonOECD in 1980 to that in 1982?
Your answer should be compact. 0.99. What is the ratio of the Population growth (in %) of Iraq in 1980 to that in 1982?
Offer a terse response. 1.06. What is the ratio of the Population growth (in %) in Morocco in 1980 to that in 1982?
Your answer should be compact. 1. What is the ratio of the Population growth (in %) in East Asia (developing only) in 1981 to that in 1982?
Make the answer very short. 0.98. What is the ratio of the Population growth (in %) of High income: nonOECD in 1981 to that in 1982?
Keep it short and to the point. 1.03. What is the ratio of the Population growth (in %) of Iraq in 1981 to that in 1982?
Offer a very short reply. 1.03. What is the ratio of the Population growth (in %) of Morocco in 1981 to that in 1982?
Ensure brevity in your answer.  1. What is the difference between the highest and the second highest Population growth (in %) of East Asia (developing only)?
Provide a short and direct response. 0.09. What is the difference between the highest and the second highest Population growth (in %) in High income: nonOECD?
Your answer should be very brief. 0.01. What is the difference between the highest and the second highest Population growth (in %) of Iraq?
Your answer should be very brief. 0.07. What is the difference between the highest and the second highest Population growth (in %) of Morocco?
Your answer should be very brief. 0. What is the difference between the highest and the lowest Population growth (in %) in East Asia (developing only)?
Your response must be concise. 2.55. What is the difference between the highest and the lowest Population growth (in %) in High income: nonOECD?
Offer a very short reply. 0.24. What is the difference between the highest and the lowest Population growth (in %) in Iraq?
Keep it short and to the point. 1.14. What is the difference between the highest and the lowest Population growth (in %) in Morocco?
Offer a very short reply. 0.06. 